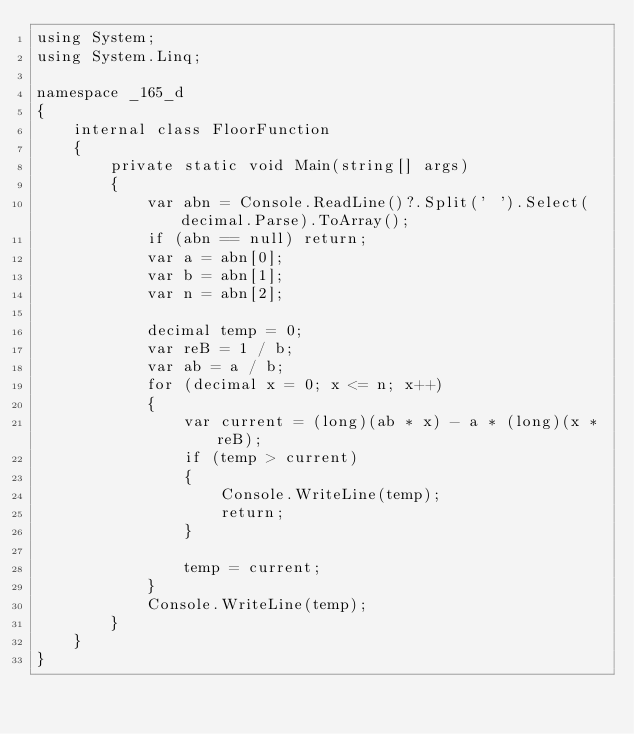Convert code to text. <code><loc_0><loc_0><loc_500><loc_500><_C#_>using System;
using System.Linq;

namespace _165_d
{
    internal class FloorFunction
    {
        private static void Main(string[] args)
        {
            var abn = Console.ReadLine()?.Split(' ').Select(decimal.Parse).ToArray();
            if (abn == null) return;
            var a = abn[0];
            var b = abn[1];
            var n = abn[2];

            decimal temp = 0;
            var reB = 1 / b;
            var ab = a / b;
            for (decimal x = 0; x <= n; x++)
            {
                var current = (long)(ab * x) - a * (long)(x * reB);
                if (temp > current)
                {
                    Console.WriteLine(temp);
                    return;
                }

                temp = current;
            }
            Console.WriteLine(temp);
        }
    }
}</code> 